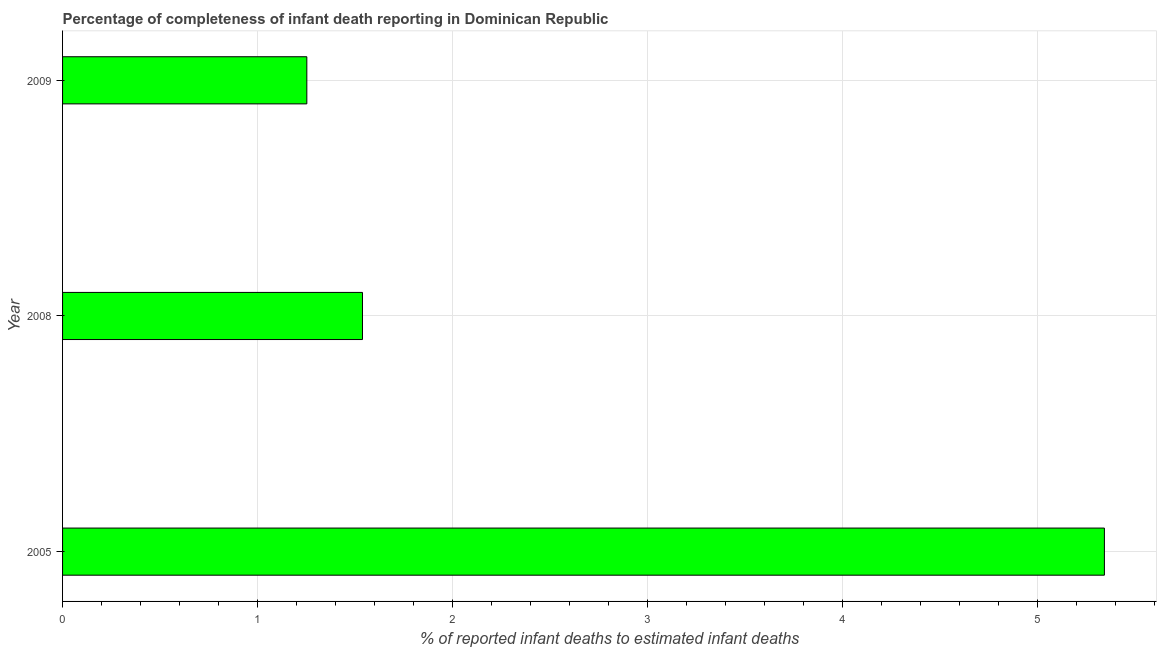Does the graph contain any zero values?
Provide a short and direct response. No. What is the title of the graph?
Your answer should be compact. Percentage of completeness of infant death reporting in Dominican Republic. What is the label or title of the X-axis?
Keep it short and to the point. % of reported infant deaths to estimated infant deaths. What is the completeness of infant death reporting in 2008?
Your response must be concise. 1.54. Across all years, what is the maximum completeness of infant death reporting?
Offer a very short reply. 5.34. Across all years, what is the minimum completeness of infant death reporting?
Make the answer very short. 1.25. In which year was the completeness of infant death reporting minimum?
Your answer should be very brief. 2009. What is the sum of the completeness of infant death reporting?
Provide a succinct answer. 8.13. What is the difference between the completeness of infant death reporting in 2005 and 2008?
Offer a terse response. 3.8. What is the average completeness of infant death reporting per year?
Offer a very short reply. 2.71. What is the median completeness of infant death reporting?
Provide a short and direct response. 1.54. Do a majority of the years between 2008 and 2009 (inclusive) have completeness of infant death reporting greater than 3.8 %?
Give a very brief answer. No. What is the ratio of the completeness of infant death reporting in 2008 to that in 2009?
Your answer should be compact. 1.23. Is the difference between the completeness of infant death reporting in 2005 and 2009 greater than the difference between any two years?
Your answer should be very brief. Yes. What is the difference between the highest and the second highest completeness of infant death reporting?
Your answer should be very brief. 3.8. Is the sum of the completeness of infant death reporting in 2005 and 2008 greater than the maximum completeness of infant death reporting across all years?
Offer a very short reply. Yes. What is the difference between the highest and the lowest completeness of infant death reporting?
Ensure brevity in your answer.  4.09. In how many years, is the completeness of infant death reporting greater than the average completeness of infant death reporting taken over all years?
Ensure brevity in your answer.  1. How many bars are there?
Ensure brevity in your answer.  3. Are all the bars in the graph horizontal?
Your answer should be compact. Yes. How many years are there in the graph?
Make the answer very short. 3. What is the difference between two consecutive major ticks on the X-axis?
Your answer should be compact. 1. Are the values on the major ticks of X-axis written in scientific E-notation?
Offer a very short reply. No. What is the % of reported infant deaths to estimated infant deaths of 2005?
Make the answer very short. 5.34. What is the % of reported infant deaths to estimated infant deaths of 2008?
Provide a short and direct response. 1.54. What is the % of reported infant deaths to estimated infant deaths of 2009?
Your answer should be compact. 1.25. What is the difference between the % of reported infant deaths to estimated infant deaths in 2005 and 2008?
Give a very brief answer. 3.8. What is the difference between the % of reported infant deaths to estimated infant deaths in 2005 and 2009?
Give a very brief answer. 4.09. What is the difference between the % of reported infant deaths to estimated infant deaths in 2008 and 2009?
Make the answer very short. 0.29. What is the ratio of the % of reported infant deaths to estimated infant deaths in 2005 to that in 2008?
Your answer should be compact. 3.47. What is the ratio of the % of reported infant deaths to estimated infant deaths in 2005 to that in 2009?
Provide a short and direct response. 4.26. What is the ratio of the % of reported infant deaths to estimated infant deaths in 2008 to that in 2009?
Keep it short and to the point. 1.23. 